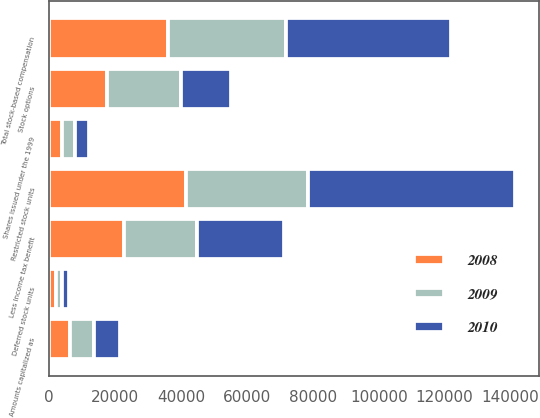<chart> <loc_0><loc_0><loc_500><loc_500><stacked_bar_chart><ecel><fcel>Stock options<fcel>Deferred stock units<fcel>Restricted stock units<fcel>Shares issued under the 1999<fcel>Amounts capitalized as<fcel>Total stock-based compensation<fcel>Less Income tax benefit<nl><fcel>2010<fcel>15154<fcel>1885<fcel>62928<fcel>4319<fcel>7818<fcel>49902<fcel>26566<nl><fcel>2008<fcel>17636<fcel>2085<fcel>41584<fcel>3772<fcel>6280<fcel>36164<fcel>22633<nl><fcel>2009<fcel>22381<fcel>1885<fcel>37005<fcel>4064<fcel>7436<fcel>35830<fcel>22069<nl></chart> 